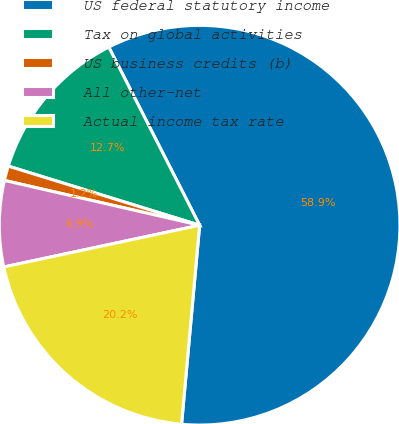Convert chart to OTSL. <chart><loc_0><loc_0><loc_500><loc_500><pie_chart><fcel>US federal statutory income<fcel>Tax on global activities<fcel>US business credits (b)<fcel>All other-net<fcel>Actual income tax rate<nl><fcel>58.93%<fcel>12.73%<fcel>1.18%<fcel>6.95%<fcel>20.21%<nl></chart> 